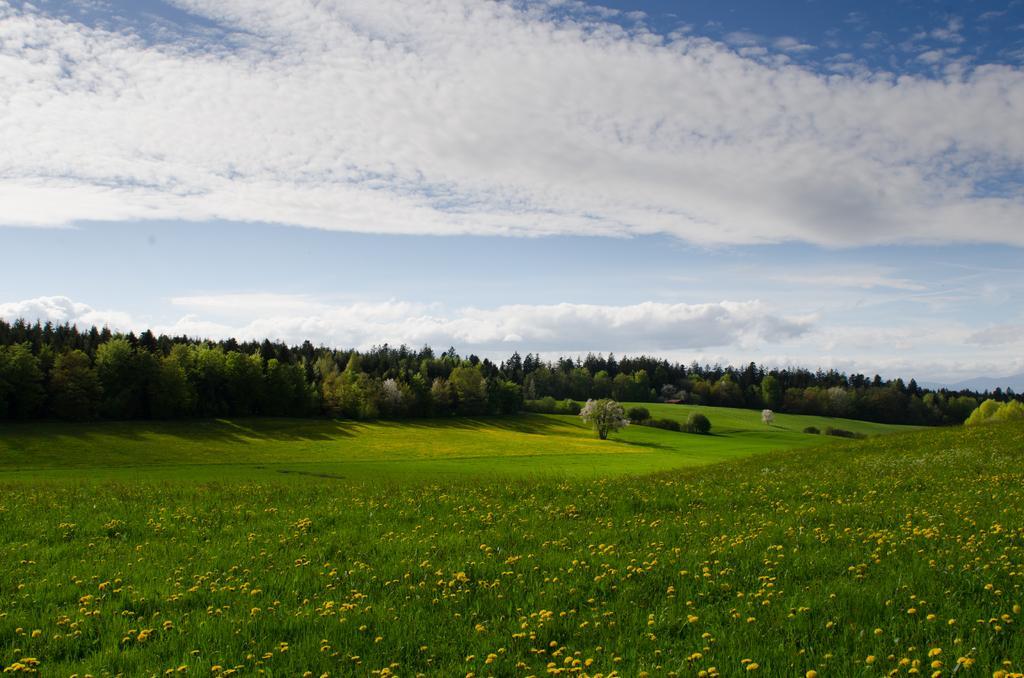Describe this image in one or two sentences. In this picture we can observe some flower plants on the ground. There is some grass. In a background there are some trees and a sky with some clouds. 